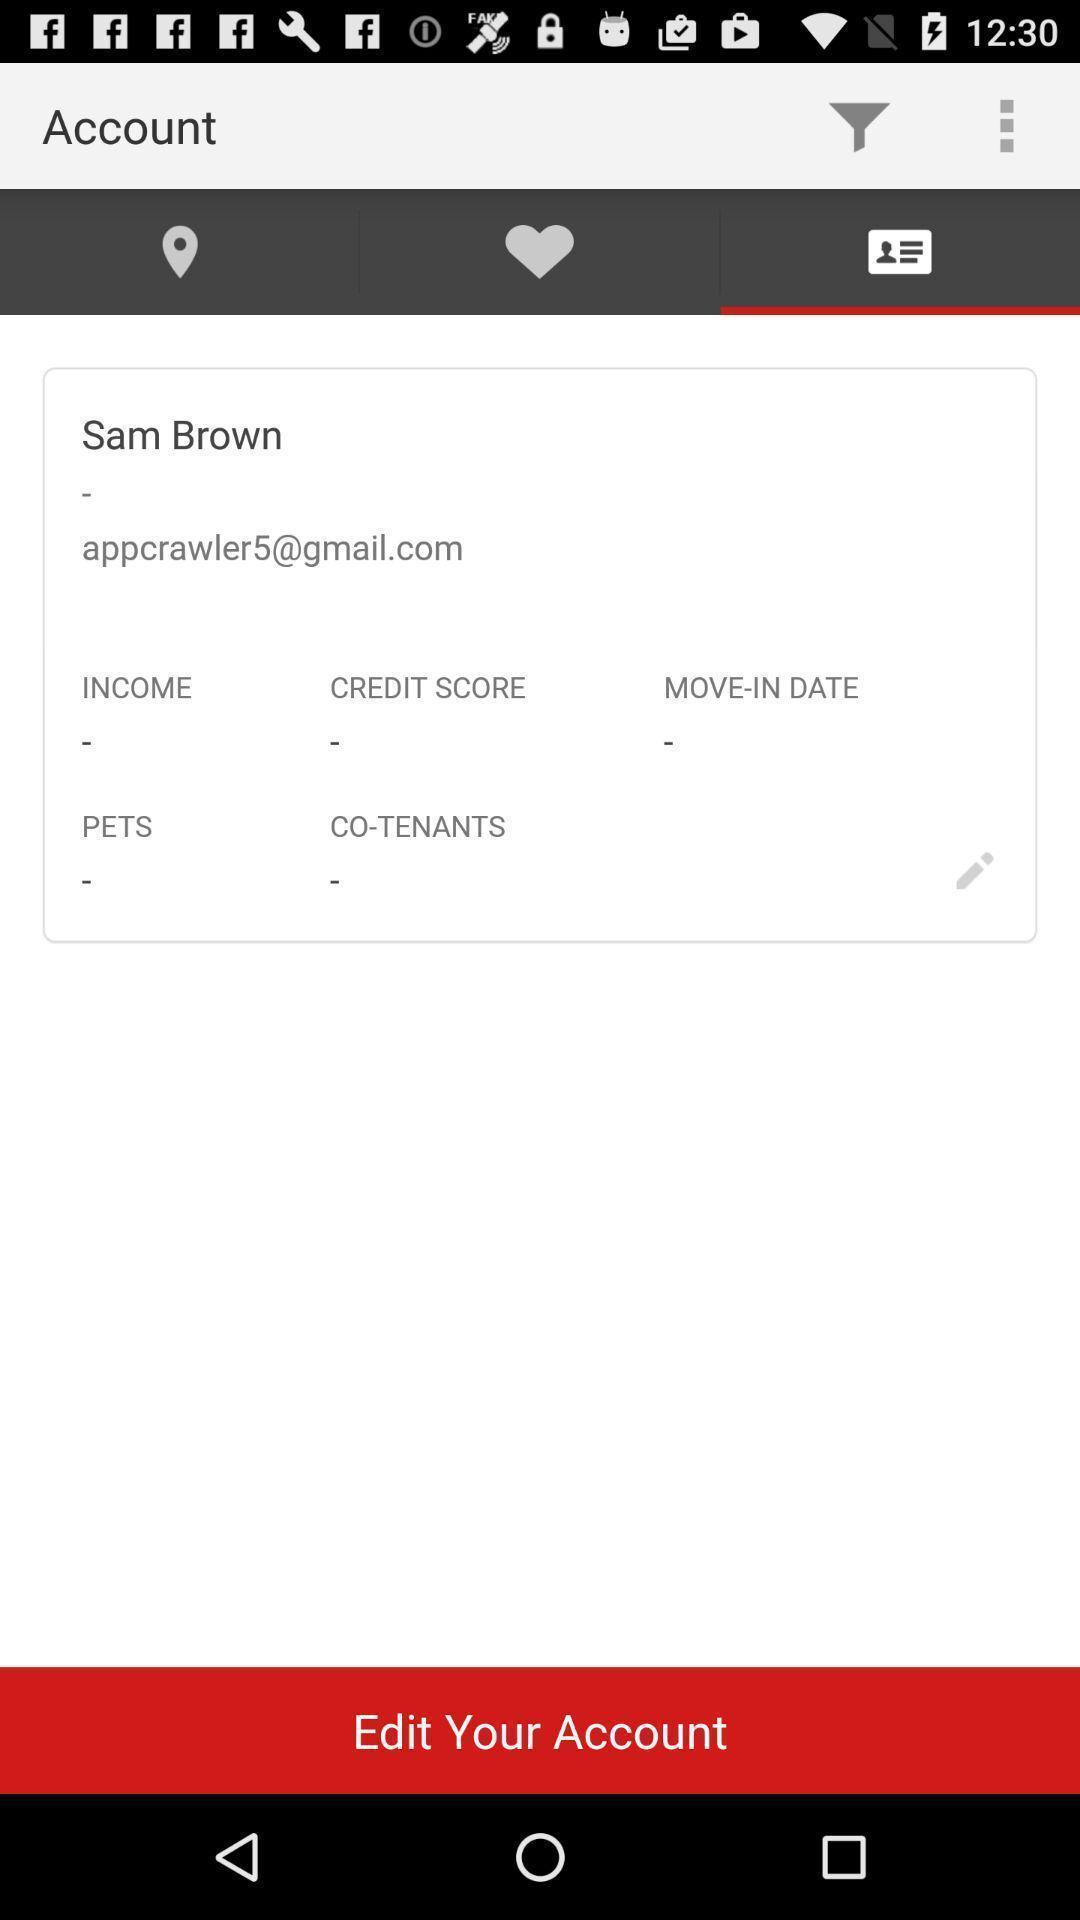Summarize the information in this screenshot. Page displaying option to edit your account with multiple icons. 